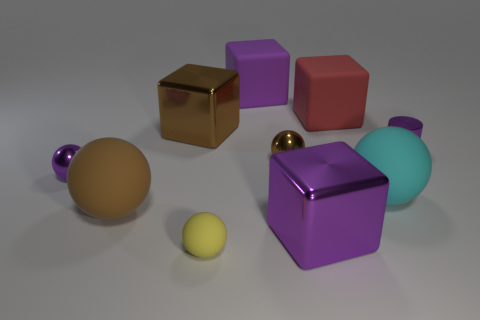Subtract all big purple metallic blocks. How many blocks are left? 3 Subtract all brown cubes. How many cubes are left? 3 Subtract all green cylinders. How many blue cubes are left? 0 Subtract all blocks. How many objects are left? 6 Subtract all large rubber things. Subtract all purple cylinders. How many objects are left? 5 Add 3 purple blocks. How many purple blocks are left? 5 Add 5 tiny yellow objects. How many tiny yellow objects exist? 6 Subtract 1 brown cubes. How many objects are left? 9 Subtract 2 spheres. How many spheres are left? 3 Subtract all yellow cylinders. Subtract all purple spheres. How many cylinders are left? 1 